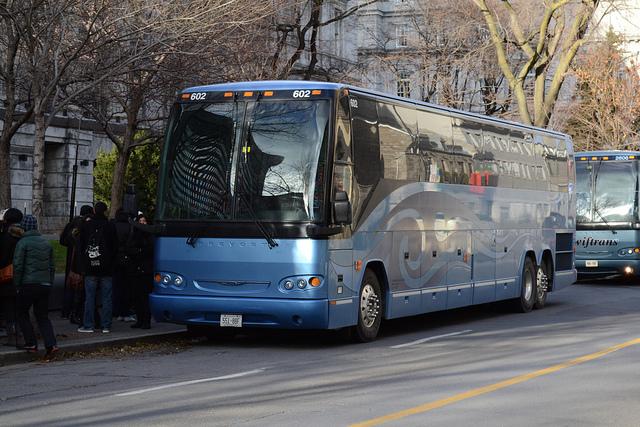What color is the bus?
Answer briefly. Blue. Is there only 1 bus?
Write a very short answer. No. How many tires are there?
Write a very short answer. 3. 